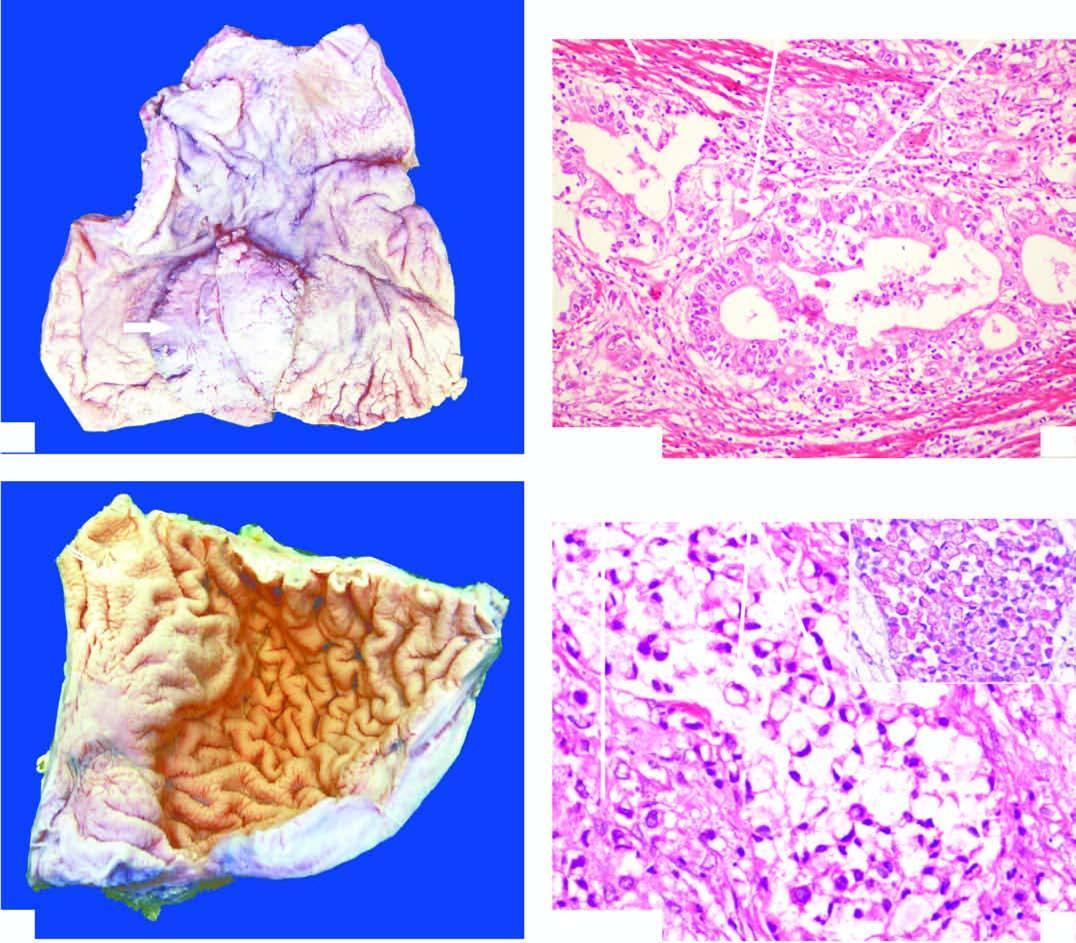what are seen invading the layers of the stomach wall?
Answer the question using a single word or phrase. Malignant cells forming irregular glands with stratification wall 